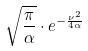<formula> <loc_0><loc_0><loc_500><loc_500>\sqrt { \frac { \pi } { \alpha } } \cdot e ^ { - \frac { \nu ^ { 2 } } { 4 \alpha } }</formula> 